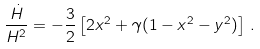Convert formula to latex. <formula><loc_0><loc_0><loc_500><loc_500>\frac { \dot { H } } { H ^ { 2 } } = - \frac { 3 } { 2 } \left [ 2 x ^ { 2 } + \gamma ( 1 - x ^ { 2 } - y ^ { 2 } ) \right ] \, .</formula> 